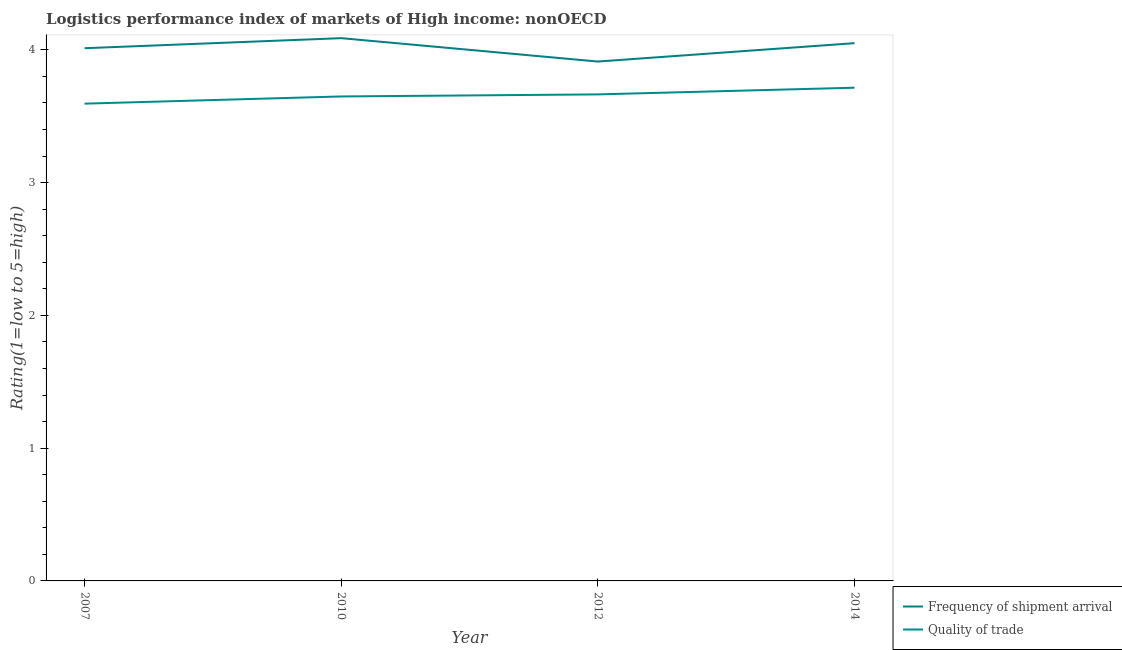How many different coloured lines are there?
Your answer should be compact. 2. Does the line corresponding to lpi of frequency of shipment arrival intersect with the line corresponding to lpi quality of trade?
Ensure brevity in your answer.  No. What is the lpi quality of trade in 2010?
Your answer should be very brief. 3.65. Across all years, what is the maximum lpi of frequency of shipment arrival?
Provide a short and direct response. 4.09. Across all years, what is the minimum lpi of frequency of shipment arrival?
Offer a very short reply. 3.91. In which year was the lpi of frequency of shipment arrival maximum?
Ensure brevity in your answer.  2010. What is the total lpi of frequency of shipment arrival in the graph?
Provide a succinct answer. 16.06. What is the difference between the lpi quality of trade in 2012 and that in 2014?
Your response must be concise. -0.05. What is the difference between the lpi quality of trade in 2012 and the lpi of frequency of shipment arrival in 2014?
Provide a succinct answer. -0.39. What is the average lpi of frequency of shipment arrival per year?
Offer a very short reply. 4.02. In the year 2007, what is the difference between the lpi quality of trade and lpi of frequency of shipment arrival?
Offer a terse response. -0.42. What is the ratio of the lpi quality of trade in 2012 to that in 2014?
Give a very brief answer. 0.99. Is the difference between the lpi quality of trade in 2012 and 2014 greater than the difference between the lpi of frequency of shipment arrival in 2012 and 2014?
Your answer should be very brief. Yes. What is the difference between the highest and the second highest lpi quality of trade?
Make the answer very short. 0.05. What is the difference between the highest and the lowest lpi quality of trade?
Provide a short and direct response. 0.12. Does the lpi quality of trade monotonically increase over the years?
Your answer should be very brief. Yes. Is the lpi of frequency of shipment arrival strictly greater than the lpi quality of trade over the years?
Your answer should be compact. Yes. How many lines are there?
Offer a very short reply. 2. Where does the legend appear in the graph?
Your answer should be compact. Bottom right. How many legend labels are there?
Offer a terse response. 2. How are the legend labels stacked?
Your answer should be very brief. Vertical. What is the title of the graph?
Offer a terse response. Logistics performance index of markets of High income: nonOECD. What is the label or title of the X-axis?
Provide a succinct answer. Year. What is the label or title of the Y-axis?
Make the answer very short. Rating(1=low to 5=high). What is the Rating(1=low to 5=high) in Frequency of shipment arrival in 2007?
Make the answer very short. 4.01. What is the Rating(1=low to 5=high) in Quality of trade in 2007?
Give a very brief answer. 3.59. What is the Rating(1=low to 5=high) of Frequency of shipment arrival in 2010?
Your response must be concise. 4.09. What is the Rating(1=low to 5=high) of Quality of trade in 2010?
Ensure brevity in your answer.  3.65. What is the Rating(1=low to 5=high) of Frequency of shipment arrival in 2012?
Keep it short and to the point. 3.91. What is the Rating(1=low to 5=high) in Quality of trade in 2012?
Your answer should be compact. 3.66. What is the Rating(1=low to 5=high) in Frequency of shipment arrival in 2014?
Provide a short and direct response. 4.05. What is the Rating(1=low to 5=high) of Quality of trade in 2014?
Provide a succinct answer. 3.71. Across all years, what is the maximum Rating(1=low to 5=high) of Frequency of shipment arrival?
Make the answer very short. 4.09. Across all years, what is the maximum Rating(1=low to 5=high) in Quality of trade?
Your answer should be very brief. 3.71. Across all years, what is the minimum Rating(1=low to 5=high) of Frequency of shipment arrival?
Give a very brief answer. 3.91. Across all years, what is the minimum Rating(1=low to 5=high) of Quality of trade?
Keep it short and to the point. 3.59. What is the total Rating(1=low to 5=high) of Frequency of shipment arrival in the graph?
Give a very brief answer. 16.06. What is the total Rating(1=low to 5=high) of Quality of trade in the graph?
Offer a very short reply. 14.62. What is the difference between the Rating(1=low to 5=high) of Frequency of shipment arrival in 2007 and that in 2010?
Your answer should be very brief. -0.08. What is the difference between the Rating(1=low to 5=high) in Quality of trade in 2007 and that in 2010?
Provide a short and direct response. -0.05. What is the difference between the Rating(1=low to 5=high) of Frequency of shipment arrival in 2007 and that in 2012?
Offer a very short reply. 0.1. What is the difference between the Rating(1=low to 5=high) of Quality of trade in 2007 and that in 2012?
Ensure brevity in your answer.  -0.07. What is the difference between the Rating(1=low to 5=high) in Frequency of shipment arrival in 2007 and that in 2014?
Provide a succinct answer. -0.04. What is the difference between the Rating(1=low to 5=high) in Quality of trade in 2007 and that in 2014?
Provide a short and direct response. -0.12. What is the difference between the Rating(1=low to 5=high) of Frequency of shipment arrival in 2010 and that in 2012?
Give a very brief answer. 0.18. What is the difference between the Rating(1=low to 5=high) of Quality of trade in 2010 and that in 2012?
Keep it short and to the point. -0.02. What is the difference between the Rating(1=low to 5=high) of Frequency of shipment arrival in 2010 and that in 2014?
Your response must be concise. 0.04. What is the difference between the Rating(1=low to 5=high) in Quality of trade in 2010 and that in 2014?
Your answer should be compact. -0.07. What is the difference between the Rating(1=low to 5=high) of Frequency of shipment arrival in 2012 and that in 2014?
Your answer should be compact. -0.14. What is the difference between the Rating(1=low to 5=high) in Quality of trade in 2012 and that in 2014?
Your response must be concise. -0.05. What is the difference between the Rating(1=low to 5=high) in Frequency of shipment arrival in 2007 and the Rating(1=low to 5=high) in Quality of trade in 2010?
Ensure brevity in your answer.  0.36. What is the difference between the Rating(1=low to 5=high) in Frequency of shipment arrival in 2007 and the Rating(1=low to 5=high) in Quality of trade in 2012?
Offer a terse response. 0.35. What is the difference between the Rating(1=low to 5=high) of Frequency of shipment arrival in 2007 and the Rating(1=low to 5=high) of Quality of trade in 2014?
Your answer should be very brief. 0.3. What is the difference between the Rating(1=low to 5=high) in Frequency of shipment arrival in 2010 and the Rating(1=low to 5=high) in Quality of trade in 2012?
Offer a terse response. 0.42. What is the difference between the Rating(1=low to 5=high) in Frequency of shipment arrival in 2010 and the Rating(1=low to 5=high) in Quality of trade in 2014?
Keep it short and to the point. 0.37. What is the difference between the Rating(1=low to 5=high) of Frequency of shipment arrival in 2012 and the Rating(1=low to 5=high) of Quality of trade in 2014?
Keep it short and to the point. 0.2. What is the average Rating(1=low to 5=high) of Frequency of shipment arrival per year?
Ensure brevity in your answer.  4.02. What is the average Rating(1=low to 5=high) of Quality of trade per year?
Give a very brief answer. 3.66. In the year 2007, what is the difference between the Rating(1=low to 5=high) in Frequency of shipment arrival and Rating(1=low to 5=high) in Quality of trade?
Offer a very short reply. 0.42. In the year 2010, what is the difference between the Rating(1=low to 5=high) of Frequency of shipment arrival and Rating(1=low to 5=high) of Quality of trade?
Give a very brief answer. 0.44. In the year 2012, what is the difference between the Rating(1=low to 5=high) in Frequency of shipment arrival and Rating(1=low to 5=high) in Quality of trade?
Your answer should be compact. 0.25. In the year 2014, what is the difference between the Rating(1=low to 5=high) in Frequency of shipment arrival and Rating(1=low to 5=high) in Quality of trade?
Provide a short and direct response. 0.34. What is the ratio of the Rating(1=low to 5=high) of Frequency of shipment arrival in 2007 to that in 2010?
Your answer should be compact. 0.98. What is the ratio of the Rating(1=low to 5=high) in Quality of trade in 2007 to that in 2010?
Your answer should be compact. 0.99. What is the ratio of the Rating(1=low to 5=high) in Frequency of shipment arrival in 2007 to that in 2012?
Offer a very short reply. 1.03. What is the ratio of the Rating(1=low to 5=high) in Quality of trade in 2007 to that in 2012?
Your answer should be very brief. 0.98. What is the ratio of the Rating(1=low to 5=high) of Frequency of shipment arrival in 2007 to that in 2014?
Make the answer very short. 0.99. What is the ratio of the Rating(1=low to 5=high) in Quality of trade in 2007 to that in 2014?
Provide a short and direct response. 0.97. What is the ratio of the Rating(1=low to 5=high) in Frequency of shipment arrival in 2010 to that in 2012?
Your answer should be compact. 1.04. What is the ratio of the Rating(1=low to 5=high) of Quality of trade in 2010 to that in 2012?
Keep it short and to the point. 1. What is the ratio of the Rating(1=low to 5=high) in Frequency of shipment arrival in 2010 to that in 2014?
Your answer should be very brief. 1.01. What is the ratio of the Rating(1=low to 5=high) of Quality of trade in 2010 to that in 2014?
Keep it short and to the point. 0.98. What is the ratio of the Rating(1=low to 5=high) in Frequency of shipment arrival in 2012 to that in 2014?
Your response must be concise. 0.97. What is the ratio of the Rating(1=low to 5=high) of Quality of trade in 2012 to that in 2014?
Offer a very short reply. 0.99. What is the difference between the highest and the second highest Rating(1=low to 5=high) of Frequency of shipment arrival?
Ensure brevity in your answer.  0.04. What is the difference between the highest and the second highest Rating(1=low to 5=high) of Quality of trade?
Ensure brevity in your answer.  0.05. What is the difference between the highest and the lowest Rating(1=low to 5=high) of Frequency of shipment arrival?
Provide a short and direct response. 0.18. What is the difference between the highest and the lowest Rating(1=low to 5=high) in Quality of trade?
Ensure brevity in your answer.  0.12. 